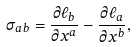Convert formula to latex. <formula><loc_0><loc_0><loc_500><loc_500>\sigma _ { a b } = \frac { \partial \ell _ { b } } { \partial x ^ { a } } - \frac { \partial \ell _ { a } } { \partial x ^ { b } } ,</formula> 